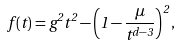<formula> <loc_0><loc_0><loc_500><loc_500>f ( t ) = g ^ { 2 } t ^ { 2 } - \left ( 1 - { \frac { \mu } { t ^ { d - 3 } } } \right ) ^ { 2 } ,</formula> 